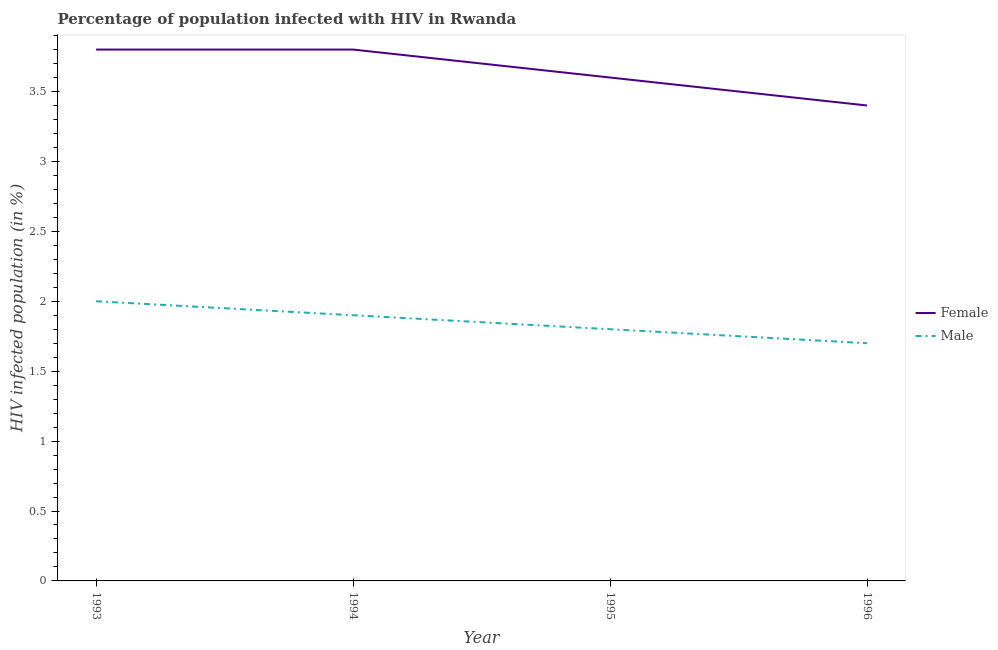Does the line corresponding to percentage of females who are infected with hiv intersect with the line corresponding to percentage of males who are infected with hiv?
Keep it short and to the point. No. Is the number of lines equal to the number of legend labels?
Your answer should be compact. Yes. What is the percentage of males who are infected with hiv in 1994?
Provide a short and direct response. 1.9. Across all years, what is the maximum percentage of females who are infected with hiv?
Provide a succinct answer. 3.8. In which year was the percentage of males who are infected with hiv minimum?
Provide a short and direct response. 1996. What is the difference between the percentage of males who are infected with hiv in 1993 and that in 1994?
Offer a very short reply. 0.1. What is the difference between the percentage of males who are infected with hiv in 1996 and the percentage of females who are infected with hiv in 1995?
Offer a very short reply. -1.9. What is the average percentage of males who are infected with hiv per year?
Keep it short and to the point. 1.85. In the year 1995, what is the difference between the percentage of females who are infected with hiv and percentage of males who are infected with hiv?
Provide a short and direct response. 1.8. What is the ratio of the percentage of females who are infected with hiv in 1993 to that in 1996?
Offer a very short reply. 1.12. Is the difference between the percentage of females who are infected with hiv in 1994 and 1995 greater than the difference between the percentage of males who are infected with hiv in 1994 and 1995?
Your answer should be very brief. Yes. What is the difference between the highest and the second highest percentage of females who are infected with hiv?
Your answer should be very brief. 0. What is the difference between the highest and the lowest percentage of males who are infected with hiv?
Provide a succinct answer. 0.3. Does the percentage of females who are infected with hiv monotonically increase over the years?
Give a very brief answer. No. Is the percentage of males who are infected with hiv strictly less than the percentage of females who are infected with hiv over the years?
Your response must be concise. Yes. How many lines are there?
Offer a very short reply. 2. What is the difference between two consecutive major ticks on the Y-axis?
Your response must be concise. 0.5. Does the graph contain grids?
Keep it short and to the point. No. Where does the legend appear in the graph?
Give a very brief answer. Center right. How are the legend labels stacked?
Provide a succinct answer. Vertical. What is the title of the graph?
Provide a succinct answer. Percentage of population infected with HIV in Rwanda. Does "Agricultural land" appear as one of the legend labels in the graph?
Provide a short and direct response. No. What is the label or title of the Y-axis?
Your response must be concise. HIV infected population (in %). What is the HIV infected population (in %) in Female in 1993?
Make the answer very short. 3.8. What is the HIV infected population (in %) of Female in 1994?
Make the answer very short. 3.8. What is the HIV infected population (in %) of Male in 1995?
Keep it short and to the point. 1.8. What is the HIV infected population (in %) of Male in 1996?
Your answer should be very brief. 1.7. Across all years, what is the maximum HIV infected population (in %) of Female?
Ensure brevity in your answer.  3.8. Across all years, what is the maximum HIV infected population (in %) in Male?
Make the answer very short. 2. Across all years, what is the minimum HIV infected population (in %) of Female?
Ensure brevity in your answer.  3.4. Across all years, what is the minimum HIV infected population (in %) in Male?
Offer a terse response. 1.7. What is the difference between the HIV infected population (in %) in Male in 1993 and that in 1994?
Make the answer very short. 0.1. What is the difference between the HIV infected population (in %) in Female in 1993 and that in 1995?
Offer a terse response. 0.2. What is the difference between the HIV infected population (in %) in Female in 1993 and that in 1996?
Keep it short and to the point. 0.4. What is the difference between the HIV infected population (in %) in Female in 1995 and that in 1996?
Your answer should be compact. 0.2. What is the difference between the HIV infected population (in %) in Female in 1993 and the HIV infected population (in %) in Male in 1996?
Give a very brief answer. 2.1. What is the difference between the HIV infected population (in %) in Female in 1994 and the HIV infected population (in %) in Male in 1995?
Offer a terse response. 2. What is the average HIV infected population (in %) of Female per year?
Offer a very short reply. 3.65. What is the average HIV infected population (in %) of Male per year?
Ensure brevity in your answer.  1.85. In the year 1993, what is the difference between the HIV infected population (in %) in Female and HIV infected population (in %) in Male?
Keep it short and to the point. 1.8. In the year 1994, what is the difference between the HIV infected population (in %) in Female and HIV infected population (in %) in Male?
Ensure brevity in your answer.  1.9. In the year 1996, what is the difference between the HIV infected population (in %) in Female and HIV infected population (in %) in Male?
Offer a terse response. 1.7. What is the ratio of the HIV infected population (in %) in Male in 1993 to that in 1994?
Your response must be concise. 1.05. What is the ratio of the HIV infected population (in %) in Female in 1993 to that in 1995?
Keep it short and to the point. 1.06. What is the ratio of the HIV infected population (in %) in Female in 1993 to that in 1996?
Your response must be concise. 1.12. What is the ratio of the HIV infected population (in %) in Male in 1993 to that in 1996?
Your response must be concise. 1.18. What is the ratio of the HIV infected population (in %) of Female in 1994 to that in 1995?
Your answer should be compact. 1.06. What is the ratio of the HIV infected population (in %) in Male in 1994 to that in 1995?
Provide a short and direct response. 1.06. What is the ratio of the HIV infected population (in %) of Female in 1994 to that in 1996?
Offer a terse response. 1.12. What is the ratio of the HIV infected population (in %) in Male in 1994 to that in 1996?
Your answer should be very brief. 1.12. What is the ratio of the HIV infected population (in %) of Female in 1995 to that in 1996?
Make the answer very short. 1.06. What is the ratio of the HIV infected population (in %) in Male in 1995 to that in 1996?
Keep it short and to the point. 1.06. What is the difference between the highest and the second highest HIV infected population (in %) in Male?
Ensure brevity in your answer.  0.1. What is the difference between the highest and the lowest HIV infected population (in %) of Male?
Your response must be concise. 0.3. 